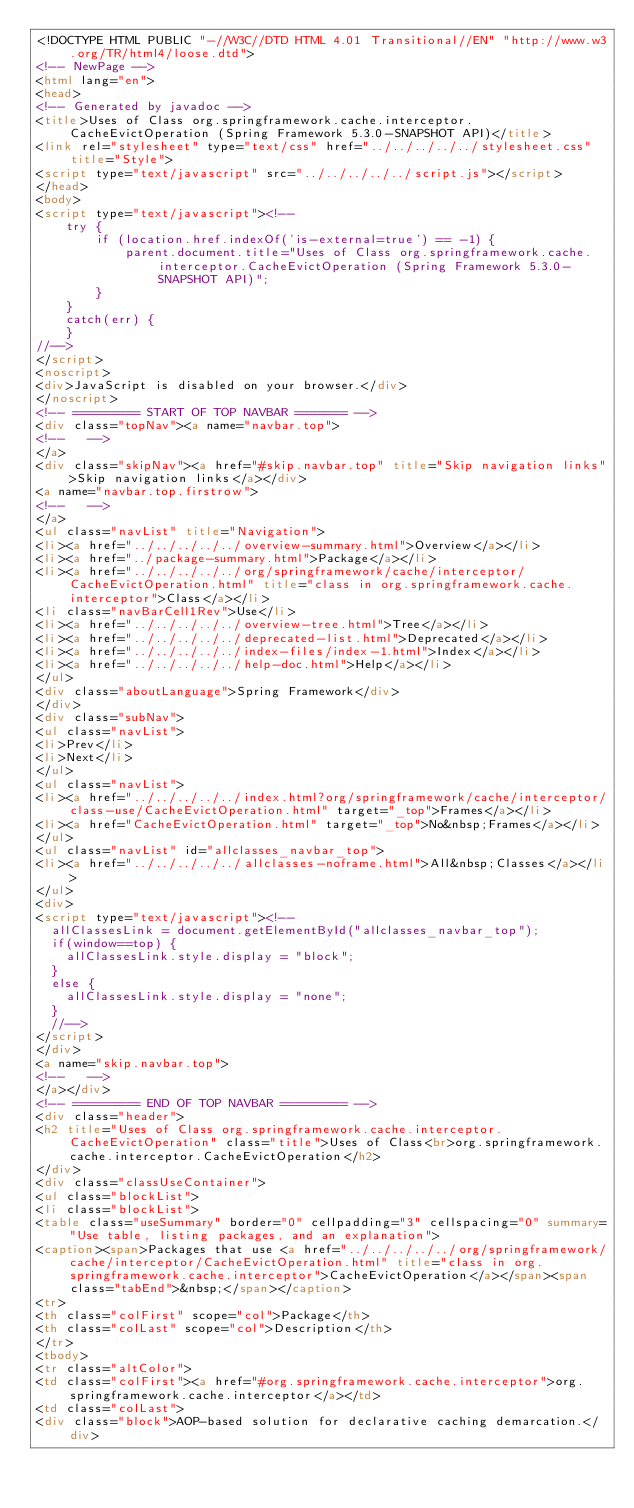Convert code to text. <code><loc_0><loc_0><loc_500><loc_500><_HTML_><!DOCTYPE HTML PUBLIC "-//W3C//DTD HTML 4.01 Transitional//EN" "http://www.w3.org/TR/html4/loose.dtd">
<!-- NewPage -->
<html lang="en">
<head>
<!-- Generated by javadoc -->
<title>Uses of Class org.springframework.cache.interceptor.CacheEvictOperation (Spring Framework 5.3.0-SNAPSHOT API)</title>
<link rel="stylesheet" type="text/css" href="../../../../../stylesheet.css" title="Style">
<script type="text/javascript" src="../../../../../script.js"></script>
</head>
<body>
<script type="text/javascript"><!--
    try {
        if (location.href.indexOf('is-external=true') == -1) {
            parent.document.title="Uses of Class org.springframework.cache.interceptor.CacheEvictOperation (Spring Framework 5.3.0-SNAPSHOT API)";
        }
    }
    catch(err) {
    }
//-->
</script>
<noscript>
<div>JavaScript is disabled on your browser.</div>
</noscript>
<!-- ========= START OF TOP NAVBAR ======= -->
<div class="topNav"><a name="navbar.top">
<!--   -->
</a>
<div class="skipNav"><a href="#skip.navbar.top" title="Skip navigation links">Skip navigation links</a></div>
<a name="navbar.top.firstrow">
<!--   -->
</a>
<ul class="navList" title="Navigation">
<li><a href="../../../../../overview-summary.html">Overview</a></li>
<li><a href="../package-summary.html">Package</a></li>
<li><a href="../../../../../org/springframework/cache/interceptor/CacheEvictOperation.html" title="class in org.springframework.cache.interceptor">Class</a></li>
<li class="navBarCell1Rev">Use</li>
<li><a href="../../../../../overview-tree.html">Tree</a></li>
<li><a href="../../../../../deprecated-list.html">Deprecated</a></li>
<li><a href="../../../../../index-files/index-1.html">Index</a></li>
<li><a href="../../../../../help-doc.html">Help</a></li>
</ul>
<div class="aboutLanguage">Spring Framework</div>
</div>
<div class="subNav">
<ul class="navList">
<li>Prev</li>
<li>Next</li>
</ul>
<ul class="navList">
<li><a href="../../../../../index.html?org/springframework/cache/interceptor/class-use/CacheEvictOperation.html" target="_top">Frames</a></li>
<li><a href="CacheEvictOperation.html" target="_top">No&nbsp;Frames</a></li>
</ul>
<ul class="navList" id="allclasses_navbar_top">
<li><a href="../../../../../allclasses-noframe.html">All&nbsp;Classes</a></li>
</ul>
<div>
<script type="text/javascript"><!--
  allClassesLink = document.getElementById("allclasses_navbar_top");
  if(window==top) {
    allClassesLink.style.display = "block";
  }
  else {
    allClassesLink.style.display = "none";
  }
  //-->
</script>
</div>
<a name="skip.navbar.top">
<!--   -->
</a></div>
<!-- ========= END OF TOP NAVBAR ========= -->
<div class="header">
<h2 title="Uses of Class org.springframework.cache.interceptor.CacheEvictOperation" class="title">Uses of Class<br>org.springframework.cache.interceptor.CacheEvictOperation</h2>
</div>
<div class="classUseContainer">
<ul class="blockList">
<li class="blockList">
<table class="useSummary" border="0" cellpadding="3" cellspacing="0" summary="Use table, listing packages, and an explanation">
<caption><span>Packages that use <a href="../../../../../org/springframework/cache/interceptor/CacheEvictOperation.html" title="class in org.springframework.cache.interceptor">CacheEvictOperation</a></span><span class="tabEnd">&nbsp;</span></caption>
<tr>
<th class="colFirst" scope="col">Package</th>
<th class="colLast" scope="col">Description</th>
</tr>
<tbody>
<tr class="altColor">
<td class="colFirst"><a href="#org.springframework.cache.interceptor">org.springframework.cache.interceptor</a></td>
<td class="colLast">
<div class="block">AOP-based solution for declarative caching demarcation.</div></code> 